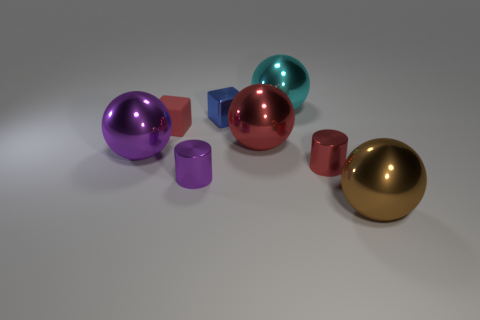Is there anything else that has the same material as the red cube?
Offer a terse response. No. Do the purple cylinder and the tiny red cube have the same material?
Keep it short and to the point. No. What size is the metal cylinder that is the same color as the small matte cube?
Keep it short and to the point. Small. Are there any other metallic cubes of the same color as the tiny metal block?
Offer a very short reply. No. There is a brown sphere that is the same material as the small blue cube; what size is it?
Ensure brevity in your answer.  Large. There is a metallic object that is on the right side of the red object right of the big shiny sphere behind the tiny blue object; what is its shape?
Your response must be concise. Sphere. There is a purple object that is the same shape as the big cyan shiny thing; what is its size?
Your answer should be compact. Large. There is a shiny object that is both left of the tiny blue metal block and in front of the big purple metal sphere; how big is it?
Your answer should be very brief. Small. The big metallic thing that is the same color as the matte thing is what shape?
Provide a succinct answer. Sphere. The metal cube has what color?
Your response must be concise. Blue. 